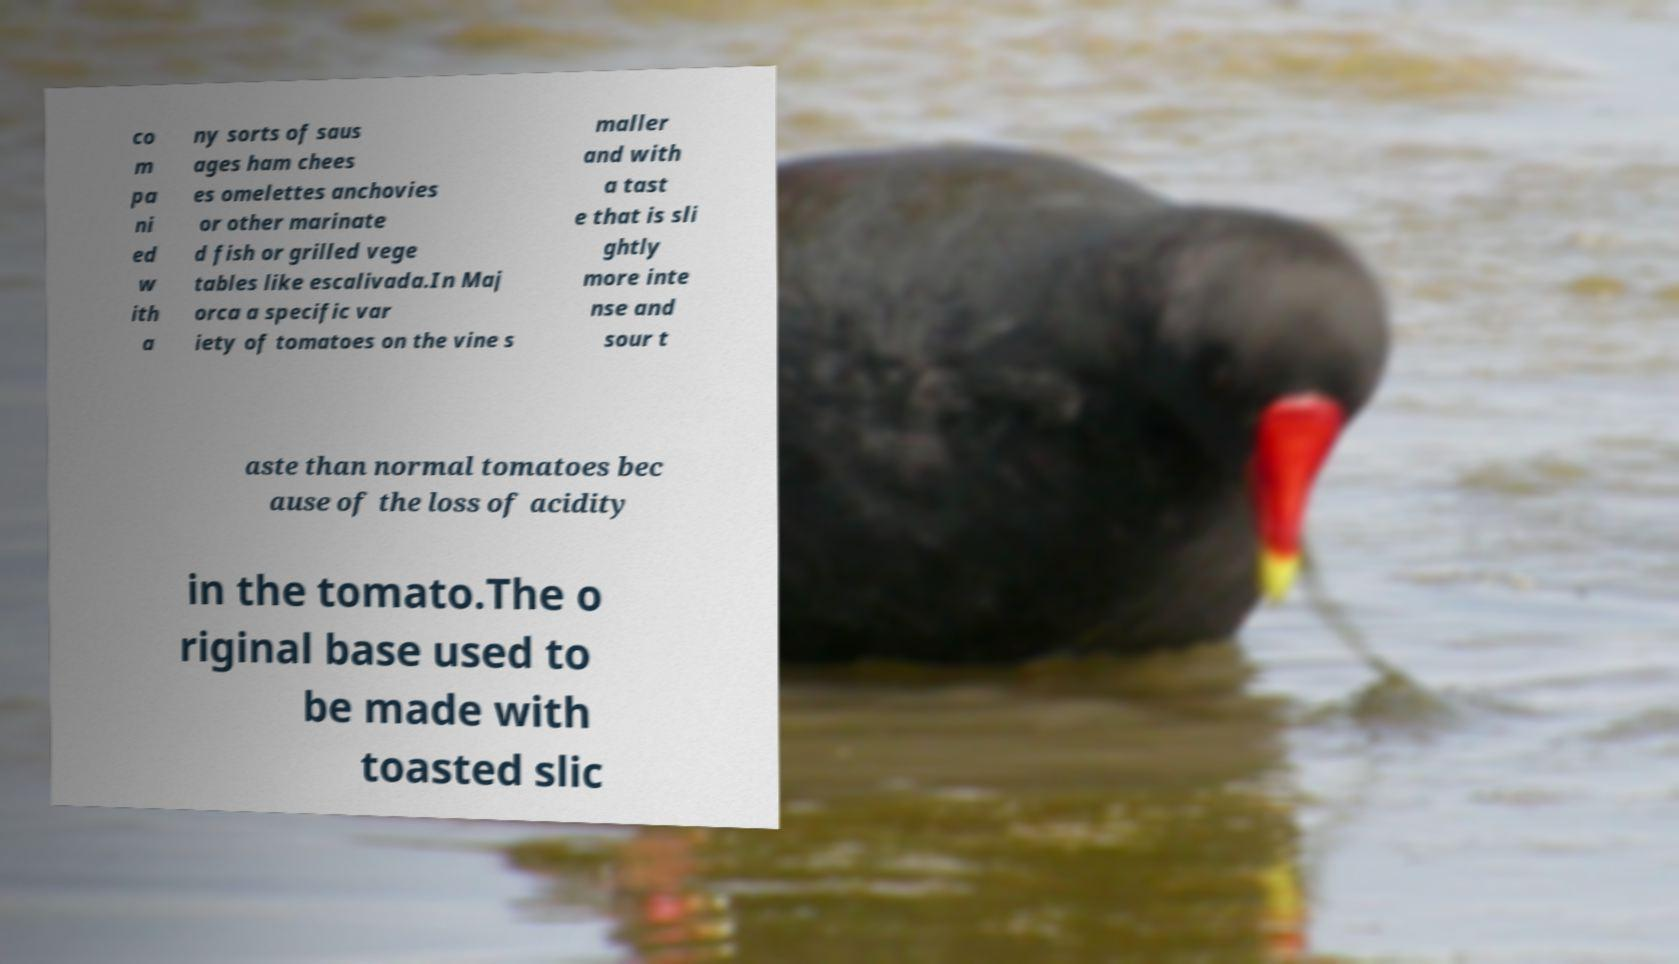Could you assist in decoding the text presented in this image and type it out clearly? co m pa ni ed w ith a ny sorts of saus ages ham chees es omelettes anchovies or other marinate d fish or grilled vege tables like escalivada.In Maj orca a specific var iety of tomatoes on the vine s maller and with a tast e that is sli ghtly more inte nse and sour t aste than normal tomatoes bec ause of the loss of acidity in the tomato.The o riginal base used to be made with toasted slic 